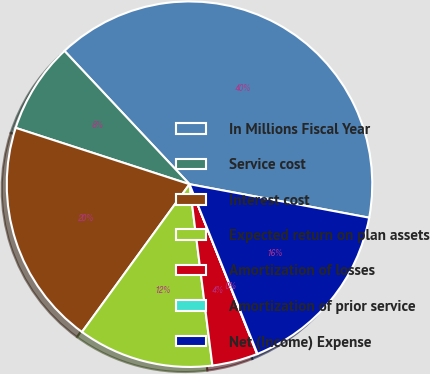<chart> <loc_0><loc_0><loc_500><loc_500><pie_chart><fcel>In Millions Fiscal Year<fcel>Service cost<fcel>Interest cost<fcel>Expected return on plan assets<fcel>Amortization of losses<fcel>Amortization of prior service<fcel>Net (Income) Expense<nl><fcel>39.93%<fcel>8.02%<fcel>19.98%<fcel>12.01%<fcel>4.03%<fcel>0.04%<fcel>16.0%<nl></chart> 